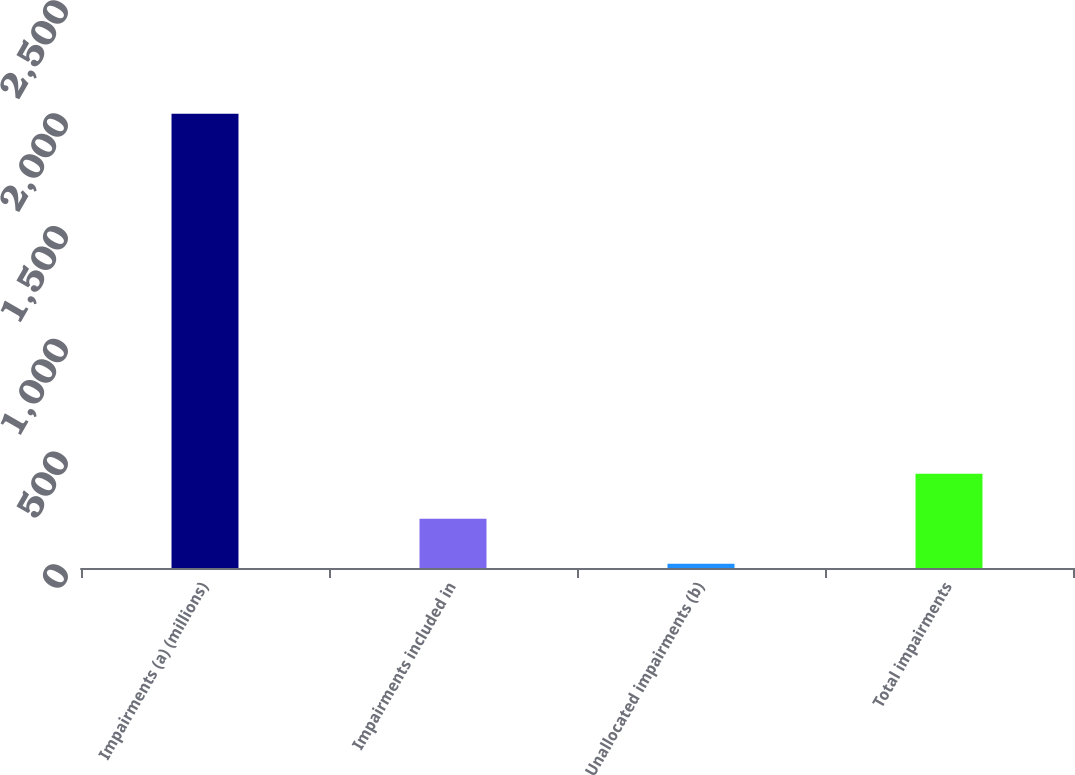Convert chart. <chart><loc_0><loc_0><loc_500><loc_500><bar_chart><fcel>Impairments (a) (millions)<fcel>Impairments included in<fcel>Unallocated impairments (b)<fcel>Total impairments<nl><fcel>2013<fcel>218.4<fcel>19<fcel>417.8<nl></chart> 